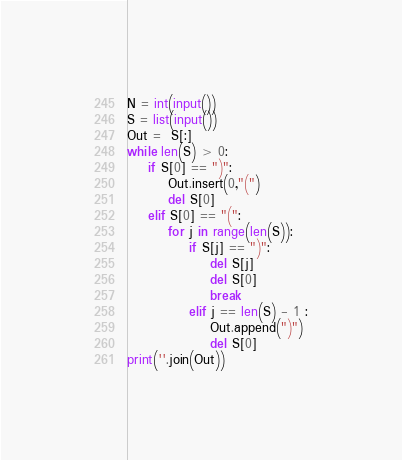Convert code to text. <code><loc_0><loc_0><loc_500><loc_500><_Python_>N = int(input())
S = list(input())
Out =  S[:]
while len(S) > 0:
	if S[0] == ")":
		Out.insert(0,"(")
		del S[0]
	elif S[0] == "(":
		for j in range(len(S)):
			if S[j] == ")":
				del S[j]
				del S[0]
				break
			elif j == len(S) - 1 :
				Out.append(")")
				del S[0]
print(''.join(Out))</code> 